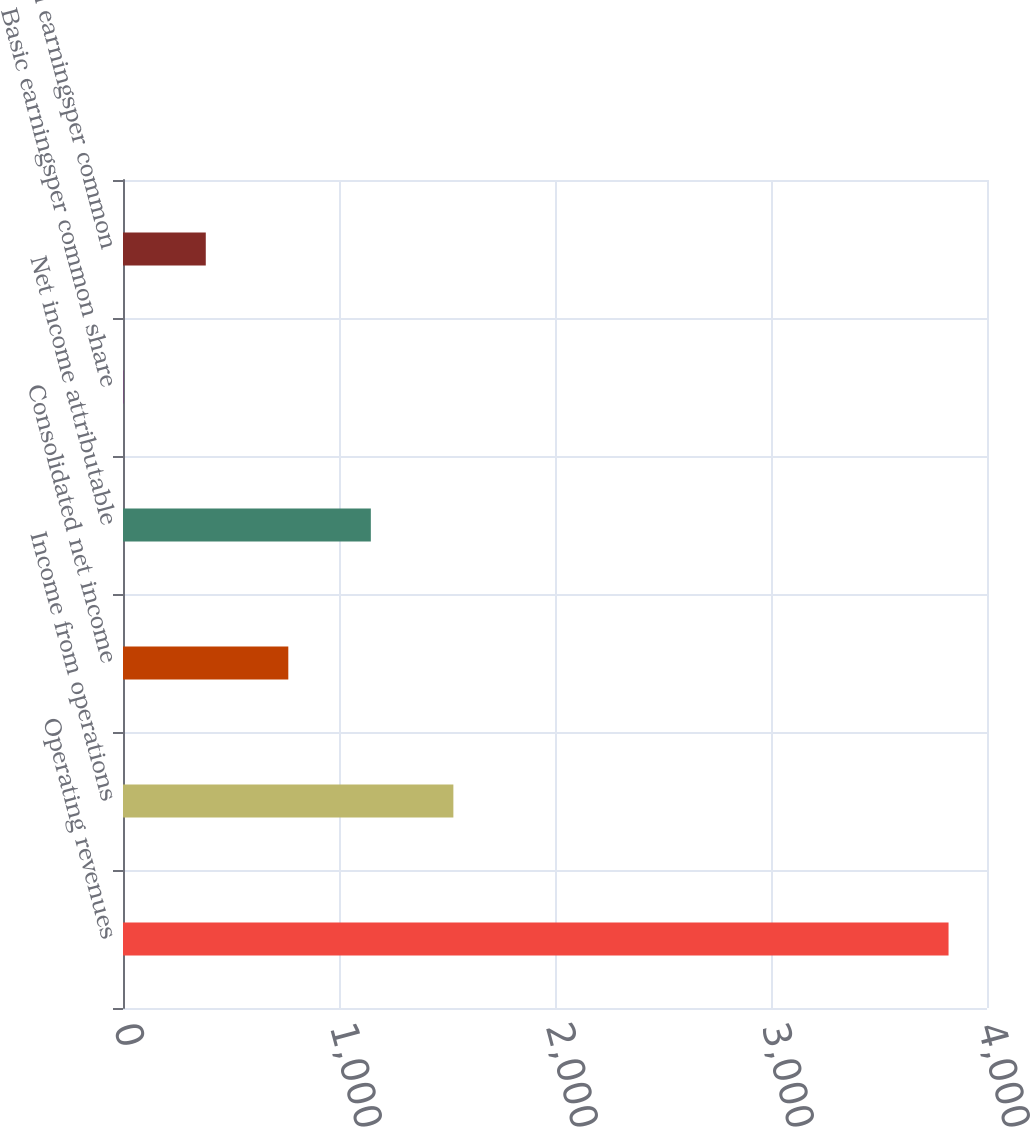<chart> <loc_0><loc_0><loc_500><loc_500><bar_chart><fcel>Operating revenues<fcel>Income from operations<fcel>Consolidated net income<fcel>Net income attributable<fcel>Basic earningsper common share<fcel>Diluted earningsper common<nl><fcel>3822<fcel>1529.48<fcel>765.32<fcel>1147.4<fcel>1.16<fcel>383.24<nl></chart> 